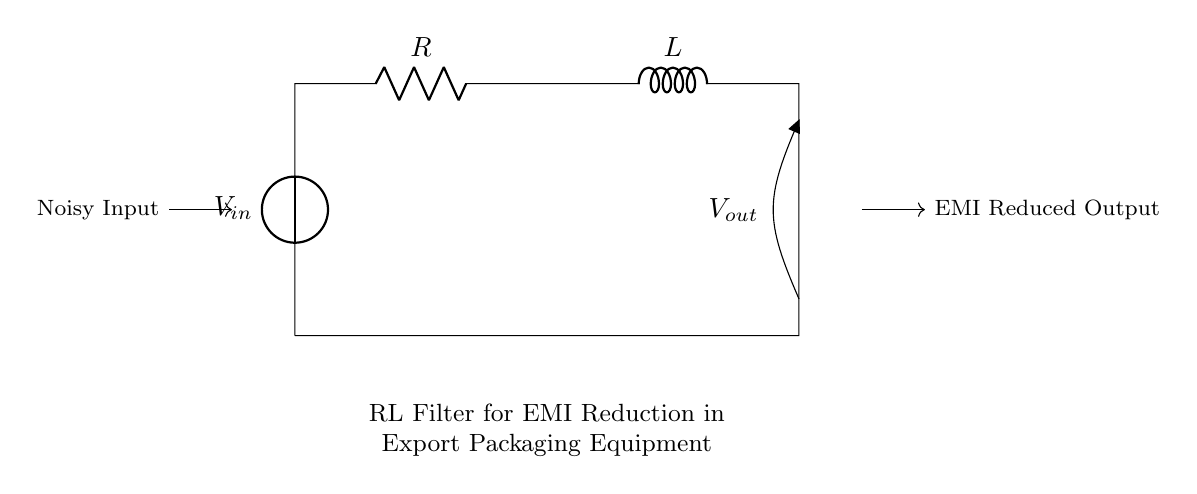What type of filter is shown in the circuit? The circuit diagram indicates it is an RL filter, which consists of a resistor and an inductor working in conjunction to filter electrical signals.
Answer: RL filter What components are used in the circuit? The circuit includes a resistor and an inductor connected in series, both vital for filtering purposes.
Answer: Resistor and inductor What is the purpose of the inductor in this circuit? The inductor serves to store energy in a magnetic field and helps to block high-frequency noise, thereby reducing electromagnetic interference.
Answer: Noise reduction What is the role of the resistor in this RL filter? The resistor creates voltage drop and dissipates energy, which helps in determining the cutoff frequency for the filter.
Answer: Determines cutoff frequency What happens to the output voltage when the input is noisy? The output voltage will be smoother and less noisy due to the filtering effect of the RL circuit, which attenuates high-frequency components.
Answer: Smoother output How are the components connected in this circuit? The components are connected in series, with the voltage source feeding into the resistor, which is then connected to the inductor.
Answer: Series connection 